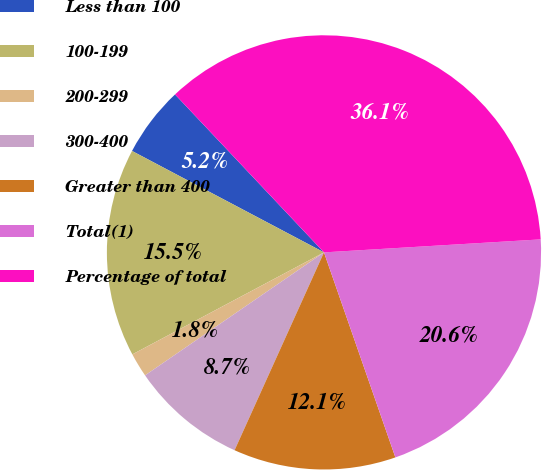Convert chart to OTSL. <chart><loc_0><loc_0><loc_500><loc_500><pie_chart><fcel>Less than 100<fcel>100-199<fcel>200-299<fcel>300-400<fcel>Greater than 400<fcel>Total(1)<fcel>Percentage of total<nl><fcel>5.23%<fcel>15.52%<fcel>1.8%<fcel>8.66%<fcel>12.09%<fcel>20.62%<fcel>36.08%<nl></chart> 